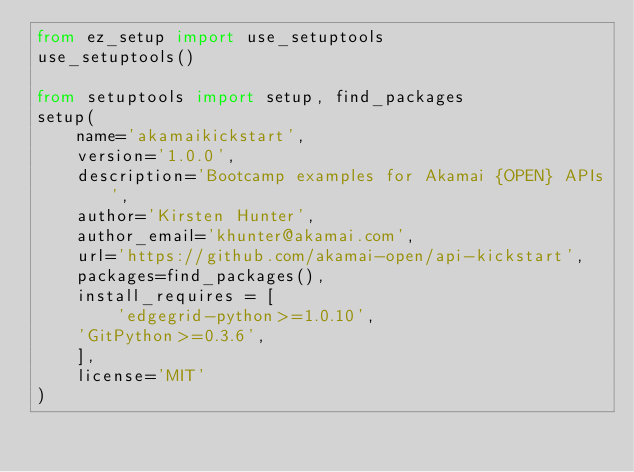Convert code to text. <code><loc_0><loc_0><loc_500><loc_500><_Python_>from ez_setup import use_setuptools
use_setuptools()

from setuptools import setup, find_packages
setup(
    name='akamaikickstart', 
    version='1.0.0', 
    description='Bootcamp examples for Akamai {OPEN} APIs',
    author='Kirsten Hunter',
    author_email='khunter@akamai.com',
    url='https://github.com/akamai-open/api-kickstart',
    packages=find_packages(),
    install_requires = [
        'edgegrid-python>=1.0.10',
	'GitPython>=0.3.6',
    ],
    license='MIT'
)
</code> 